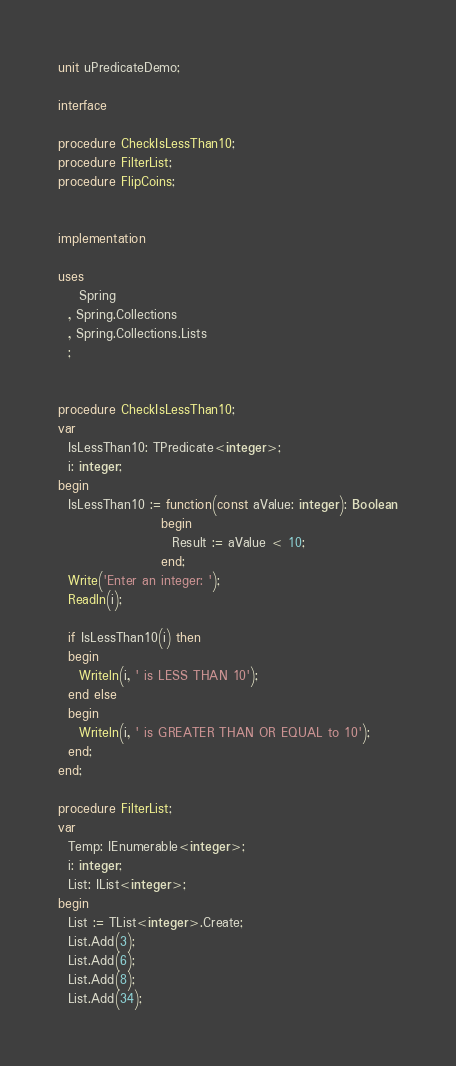Convert code to text. <code><loc_0><loc_0><loc_500><loc_500><_Pascal_>unit uPredicateDemo;

interface

procedure CheckIsLessThan10;
procedure FilterList;
procedure FlipCoins;


implementation

uses
    Spring
  , Spring.Collections
  , Spring.Collections.Lists
  ;


procedure CheckIsLessThan10;
var
  IsLessThan10: TPredicate<integer>;
  i: integer;
begin
  IsLessThan10 := function(const aValue: integer): Boolean
                    begin
                      Result := aValue < 10;
                    end;
  Write('Enter an integer: ');
  Readln(i);

  if IsLessThan10(i) then
  begin
    Writeln(i, ' is LESS THAN 10');
  end else
  begin
    Writeln(i, ' is GREATER THAN OR EQUAL to 10');
  end;
end;

procedure FilterList;
var
  Temp: IEnumerable<integer>;
  i: integer;
  List: IList<integer>;
begin
  List := TList<integer>.Create;
  List.Add(3);
  List.Add(6);
  List.Add(8);
  List.Add(34);</code> 